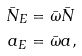<formula> <loc_0><loc_0><loc_500><loc_500>\bar { N } _ { E } & = \bar { \omega } \bar { N } \\ a _ { E } & = \bar { \omega } a ,</formula> 